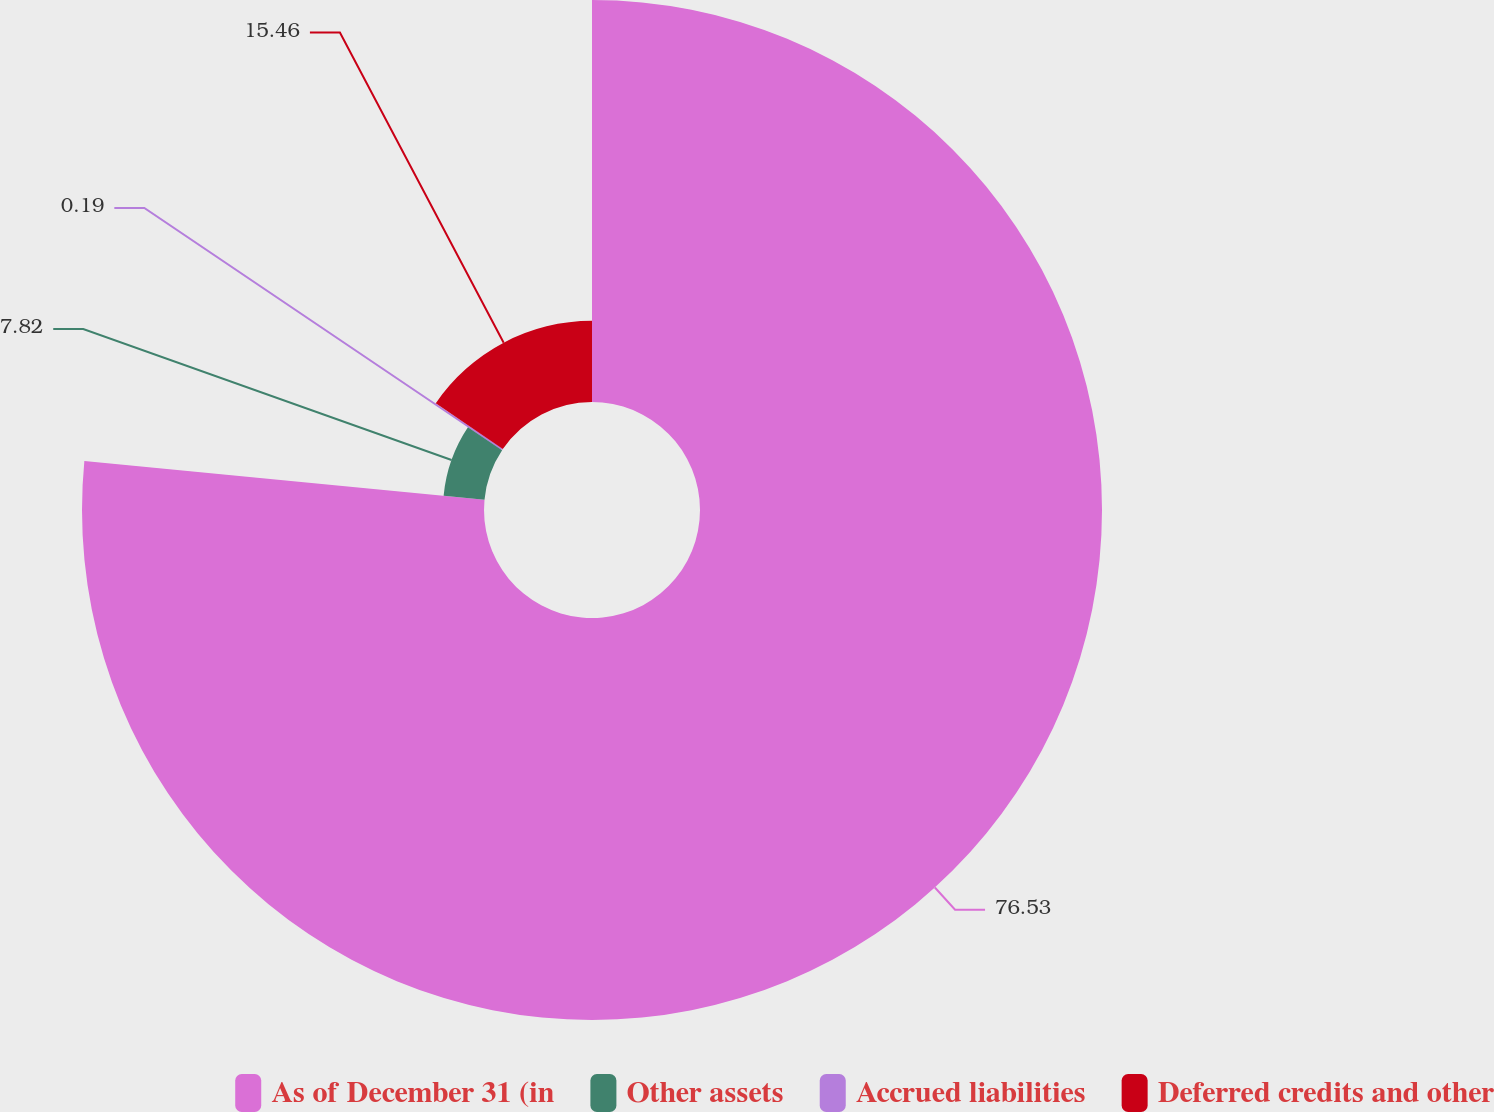Convert chart to OTSL. <chart><loc_0><loc_0><loc_500><loc_500><pie_chart><fcel>As of December 31 (in<fcel>Other assets<fcel>Accrued liabilities<fcel>Deferred credits and other<nl><fcel>76.53%<fcel>7.82%<fcel>0.19%<fcel>15.46%<nl></chart> 